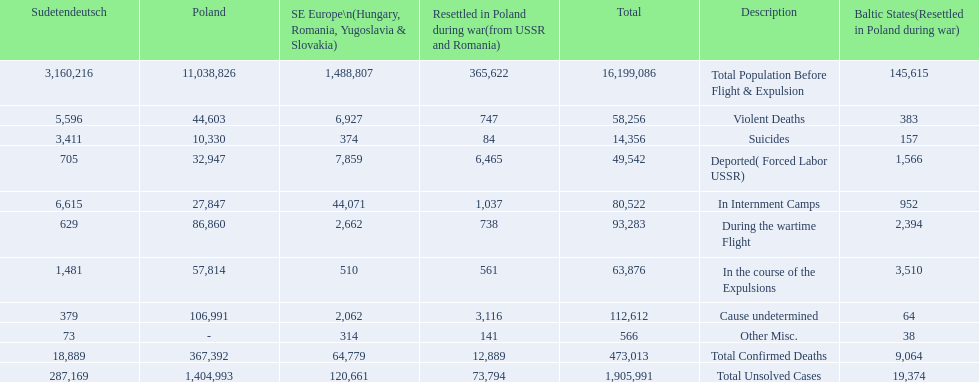How many total confirmed deaths were there in the baltic states? 9,064. How many deaths had an undetermined cause? 64. How many deaths in that region were miscellaneous? 38. Were there more deaths from an undetermined cause or that were listed as miscellaneous? Cause undetermined. 